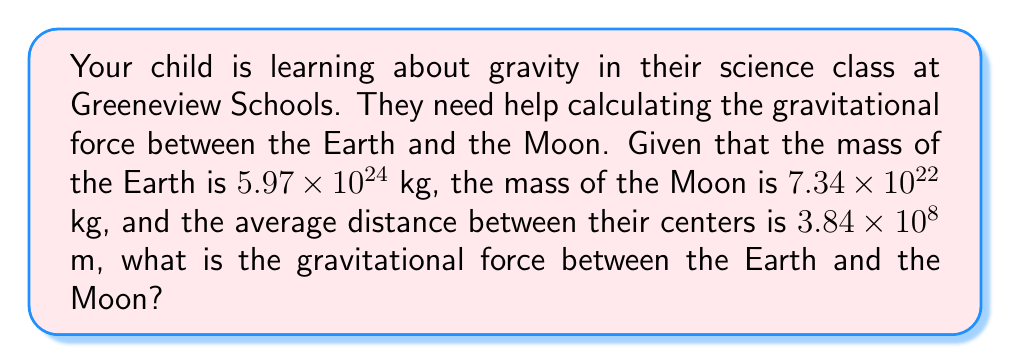Could you help me with this problem? To solve this problem, we'll use Newton's Law of Universal Gravitation:

$$F = G \frac{m_1 m_2}{r^2}$$

Where:
$F$ is the gravitational force between the two objects
$G$ is the gravitational constant, $6.67 \times 10^{-11}$ N(m/kg)²
$m_1$ is the mass of the Earth
$m_2$ is the mass of the Moon
$r$ is the distance between the centers of the Earth and Moon

Let's plug in the values:

$m_1 = 5.97 \times 10^{24}$ kg
$m_2 = 7.34 \times 10^{22}$ kg
$r = 3.84 \times 10^8$ m

Now, let's calculate:

$$\begin{align}
F &= (6.67 \times 10^{-11}) \frac{(5.97 \times 10^{24})(7.34 \times 10^{22})}{(3.84 \times 10^8)^2} \\[10pt]
&= (6.67 \times 10^{-11}) \frac{4.38 \times 10^{47}}{1.47 \times 10^{17}} \\[10pt]
&= (6.67 \times 10^{-11})(2.98 \times 10^{30}) \\[10pt]
&= 1.99 \times 10^{20} \text{ N}
\end{align}$$

Rounding to two significant figures:

$$F \approx 2.0 \times 10^{20} \text{ N}$$
Answer: $2.0 \times 10^{20}$ N 